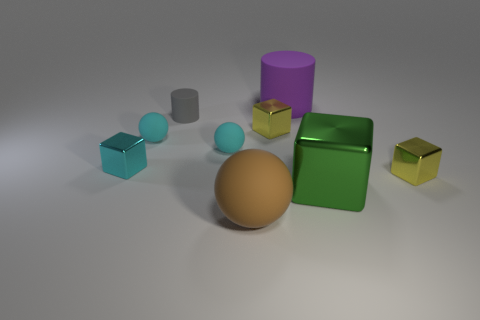What textures can be observed on the objects in this image? The objects showcase a variety of textures: the metal blocks have a smooth and reflective surface, the cylinders appear to have a matte finish, and the sphere looks to have a slightly roughened surface that diffuses the light. 